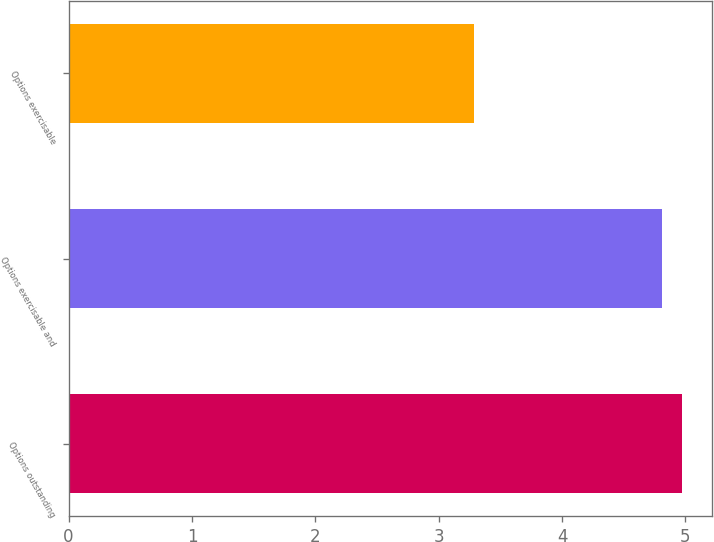Convert chart. <chart><loc_0><loc_0><loc_500><loc_500><bar_chart><fcel>Options outstanding<fcel>Options exercisable and<fcel>Options exercisable<nl><fcel>4.97<fcel>4.81<fcel>3.29<nl></chart> 